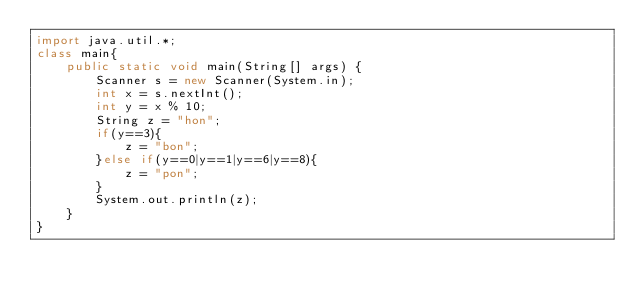<code> <loc_0><loc_0><loc_500><loc_500><_Java_>import java.util.*;
class main{
    public static void main(String[] args) {
        Scanner s = new Scanner(System.in);
        int x = s.nextInt();
        int y = x % 10;
        String z = "hon";
        if(y==3){
            z = "bon";
        }else if(y==0|y==1|y==6|y==8){
            z = "pon";
        }
        System.out.println(z);        
    }
}</code> 